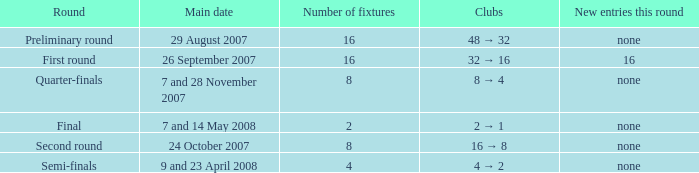What is the Round when the number of fixtures is more than 2, and the Main date of 7 and 28 november 2007? Quarter-finals. 